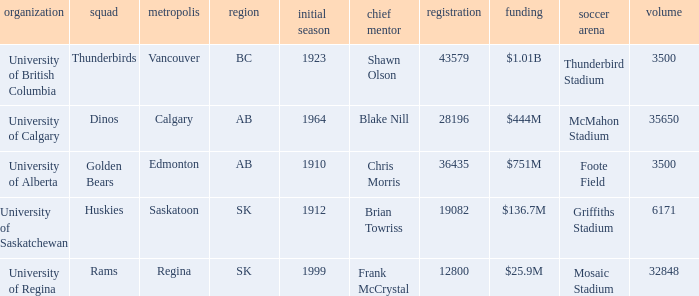Could you parse the entire table? {'header': ['organization', 'squad', 'metropolis', 'region', 'initial season', 'chief mentor', 'registration', 'funding', 'soccer arena', 'volume'], 'rows': [['University of British Columbia', 'Thunderbirds', 'Vancouver', 'BC', '1923', 'Shawn Olson', '43579', '$1.01B', 'Thunderbird Stadium', '3500'], ['University of Calgary', 'Dinos', 'Calgary', 'AB', '1964', 'Blake Nill', '28196', '$444M', 'McMahon Stadium', '35650'], ['University of Alberta', 'Golden Bears', 'Edmonton', 'AB', '1910', 'Chris Morris', '36435', '$751M', 'Foote Field', '3500'], ['University of Saskatchewan', 'Huskies', 'Saskatoon', 'SK', '1912', 'Brian Towriss', '19082', '$136.7M', 'Griffiths Stadium', '6171'], ['University of Regina', 'Rams', 'Regina', 'SK', '1999', 'Frank McCrystal', '12800', '$25.9M', 'Mosaic Stadium', '32848']]} What football stadium has a school enrollment of 43579? Thunderbird Stadium. 